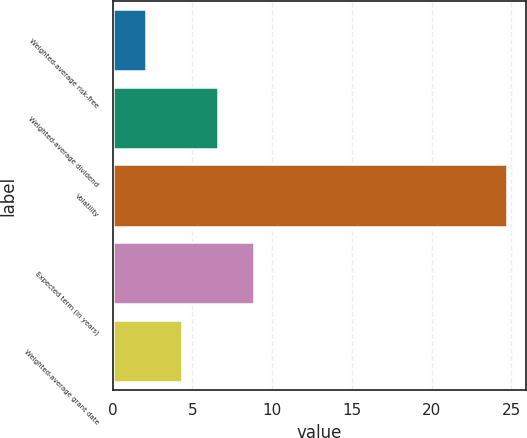Convert chart to OTSL. <chart><loc_0><loc_0><loc_500><loc_500><bar_chart><fcel>Weighted-average risk-free<fcel>Weighted-average dividend<fcel>Volatility<fcel>Expected term (in years)<fcel>Weighted-average grant date<nl><fcel>2.1<fcel>6.62<fcel>24.7<fcel>8.88<fcel>4.36<nl></chart> 